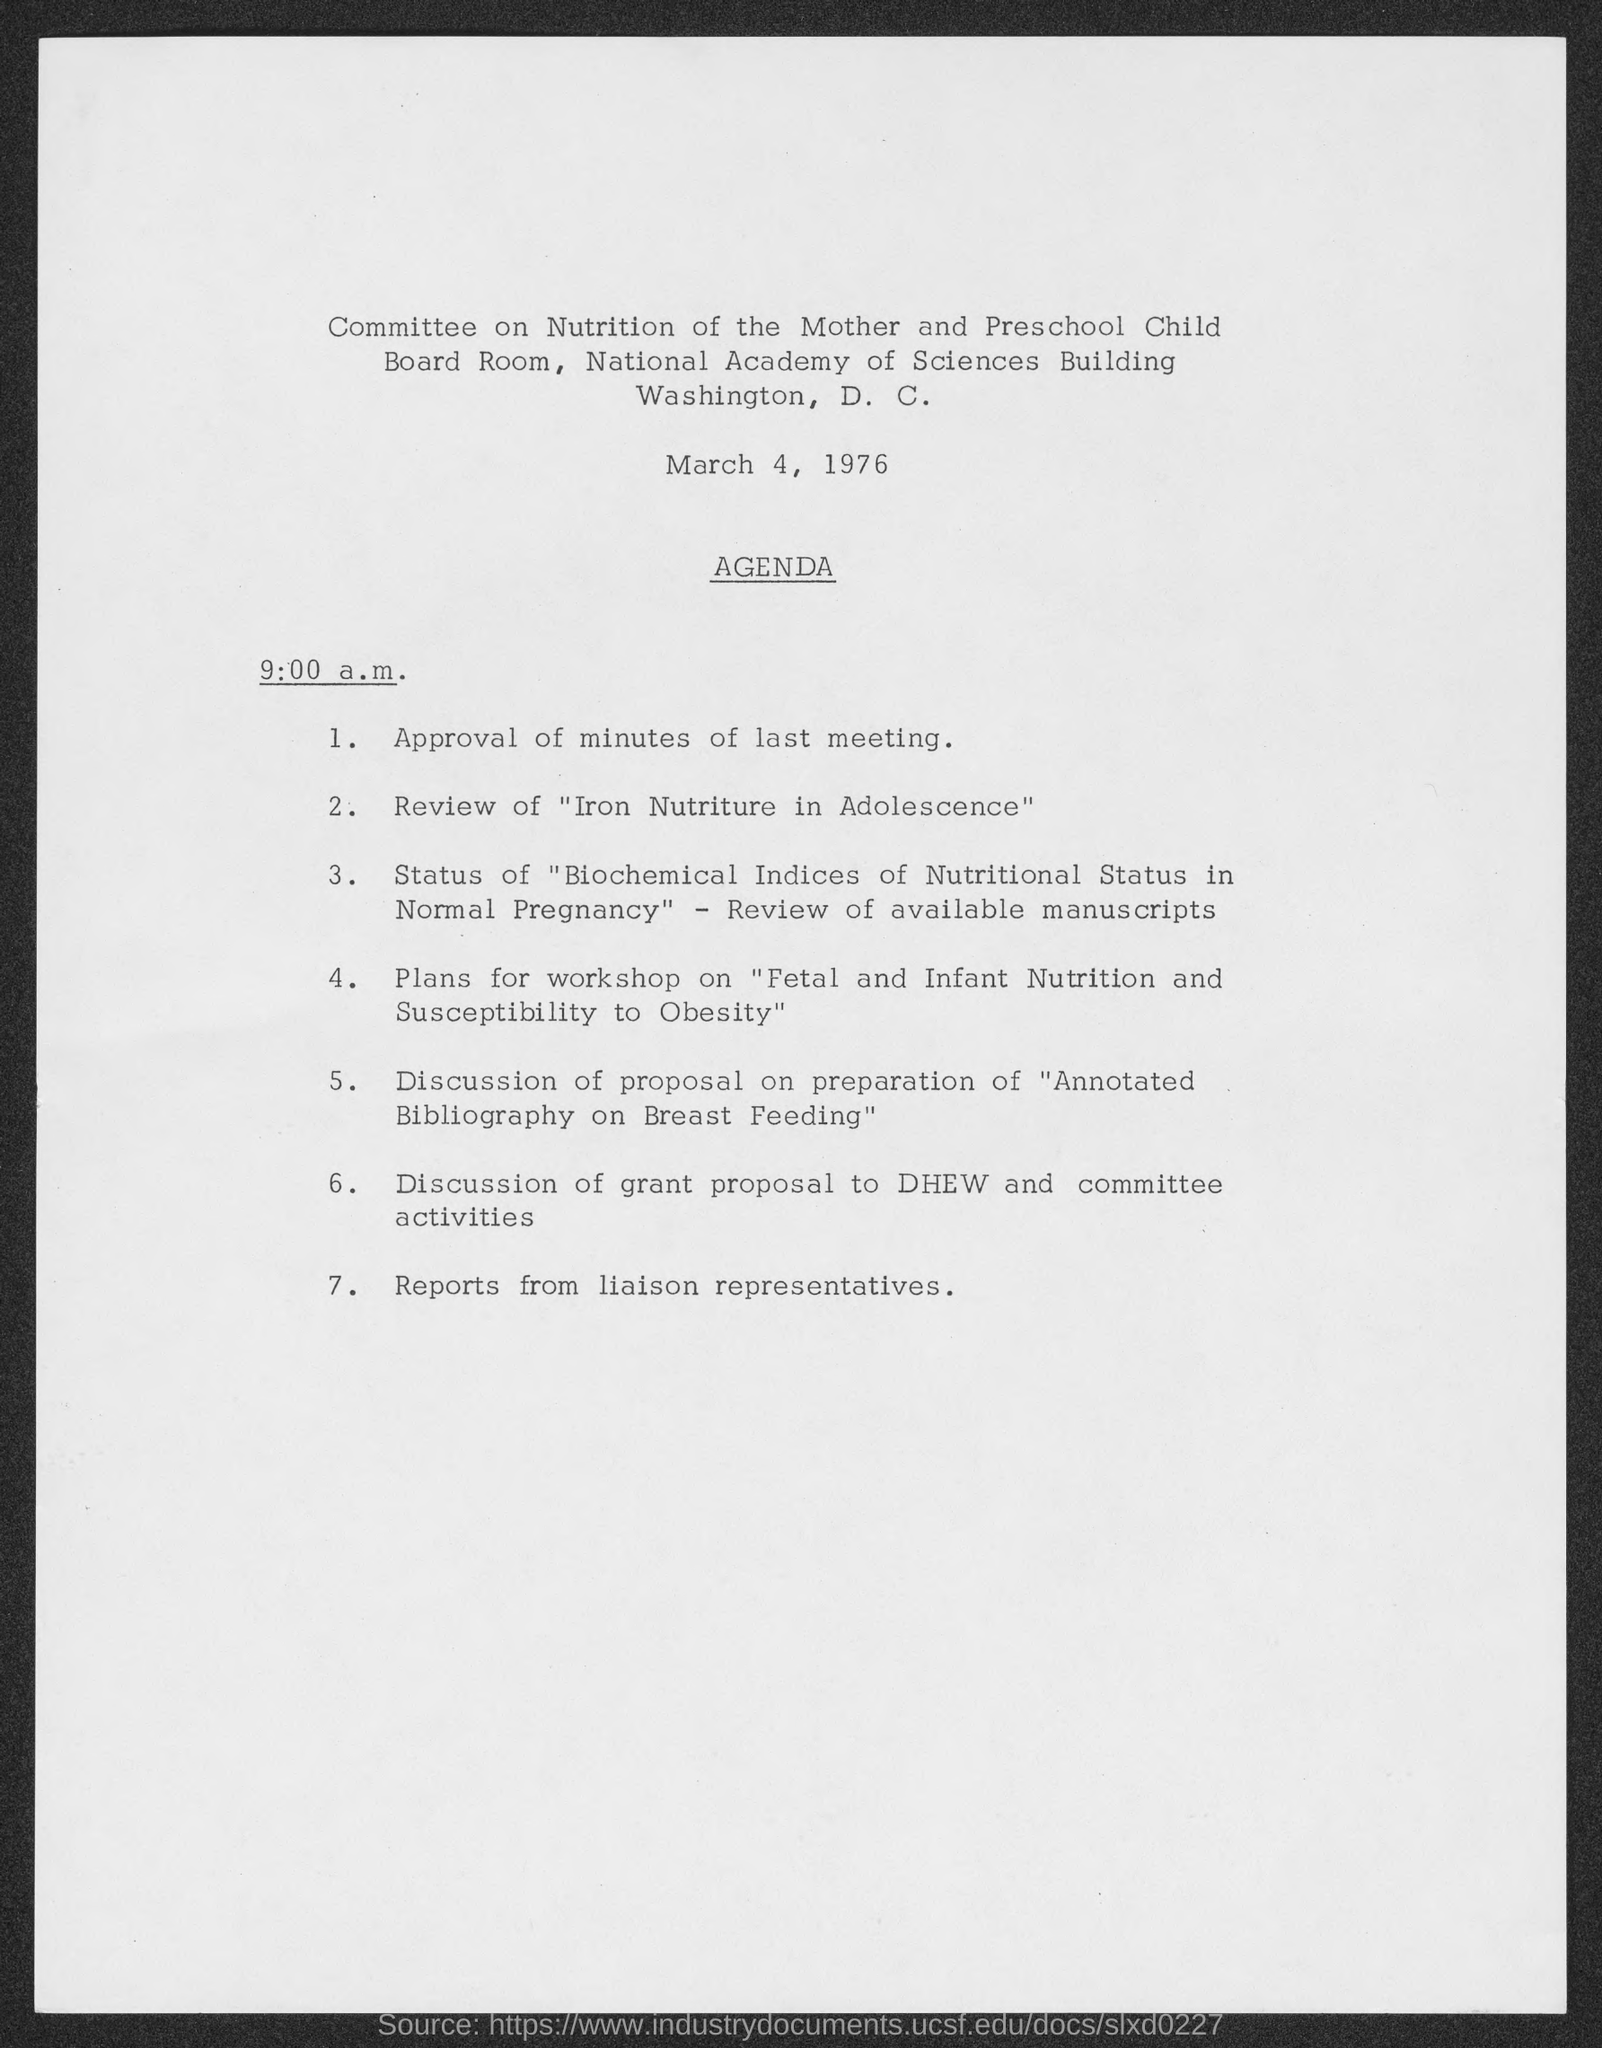Give some essential details in this illustration. The date mentioned in the document is March 4, 1976. It is currently 9:00 a.m. 